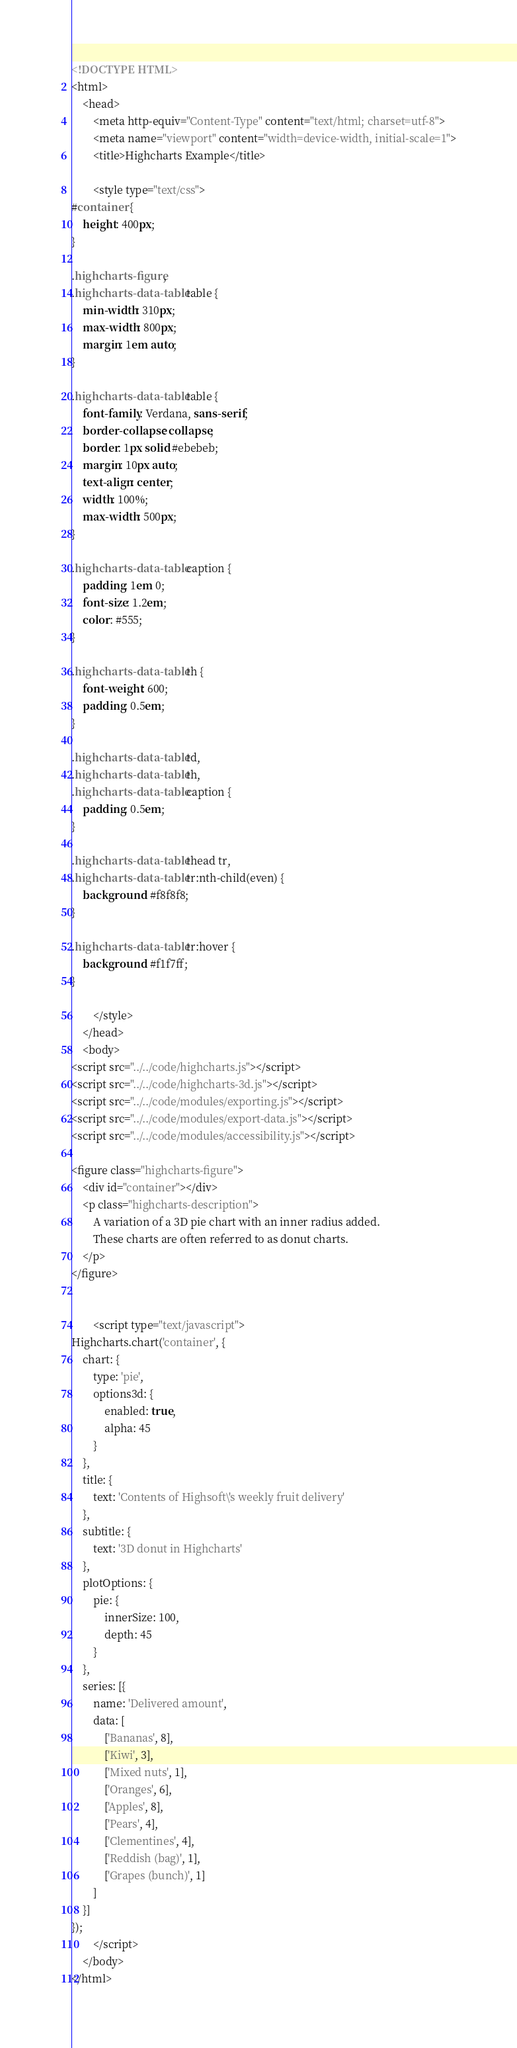<code> <loc_0><loc_0><loc_500><loc_500><_HTML_><!DOCTYPE HTML>
<html>
	<head>
		<meta http-equiv="Content-Type" content="text/html; charset=utf-8">
		<meta name="viewport" content="width=device-width, initial-scale=1">
		<title>Highcharts Example</title>

		<style type="text/css">
#container {
    height: 400px;
}

.highcharts-figure,
.highcharts-data-table table {
    min-width: 310px;
    max-width: 800px;
    margin: 1em auto;
}

.highcharts-data-table table {
    font-family: Verdana, sans-serif;
    border-collapse: collapse;
    border: 1px solid #ebebeb;
    margin: 10px auto;
    text-align: center;
    width: 100%;
    max-width: 500px;
}

.highcharts-data-table caption {
    padding: 1em 0;
    font-size: 1.2em;
    color: #555;
}

.highcharts-data-table th {
    font-weight: 600;
    padding: 0.5em;
}

.highcharts-data-table td,
.highcharts-data-table th,
.highcharts-data-table caption {
    padding: 0.5em;
}

.highcharts-data-table thead tr,
.highcharts-data-table tr:nth-child(even) {
    background: #f8f8f8;
}

.highcharts-data-table tr:hover {
    background: #f1f7ff;
}

		</style>
	</head>
	<body>
<script src="../../code/highcharts.js"></script>
<script src="../../code/highcharts-3d.js"></script>
<script src="../../code/modules/exporting.js"></script>
<script src="../../code/modules/export-data.js"></script>
<script src="../../code/modules/accessibility.js"></script>

<figure class="highcharts-figure">
    <div id="container"></div>
    <p class="highcharts-description">
        A variation of a 3D pie chart with an inner radius added.
        These charts are often referred to as donut charts.
    </p>
</figure>


		<script type="text/javascript">
Highcharts.chart('container', {
    chart: {
        type: 'pie',
        options3d: {
            enabled: true,
            alpha: 45
        }
    },
    title: {
        text: 'Contents of Highsoft\'s weekly fruit delivery'
    },
    subtitle: {
        text: '3D donut in Highcharts'
    },
    plotOptions: {
        pie: {
            innerSize: 100,
            depth: 45
        }
    },
    series: [{
        name: 'Delivered amount',
        data: [
            ['Bananas', 8],
            ['Kiwi', 3],
            ['Mixed nuts', 1],
            ['Oranges', 6],
            ['Apples', 8],
            ['Pears', 4],
            ['Clementines', 4],
            ['Reddish (bag)', 1],
            ['Grapes (bunch)', 1]
        ]
    }]
});
		</script>
	</body>
</html>
</code> 